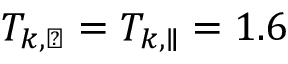<formula> <loc_0><loc_0><loc_500><loc_500>T _ { k , \perp } = T _ { k , \| } = 1 . 6</formula> 